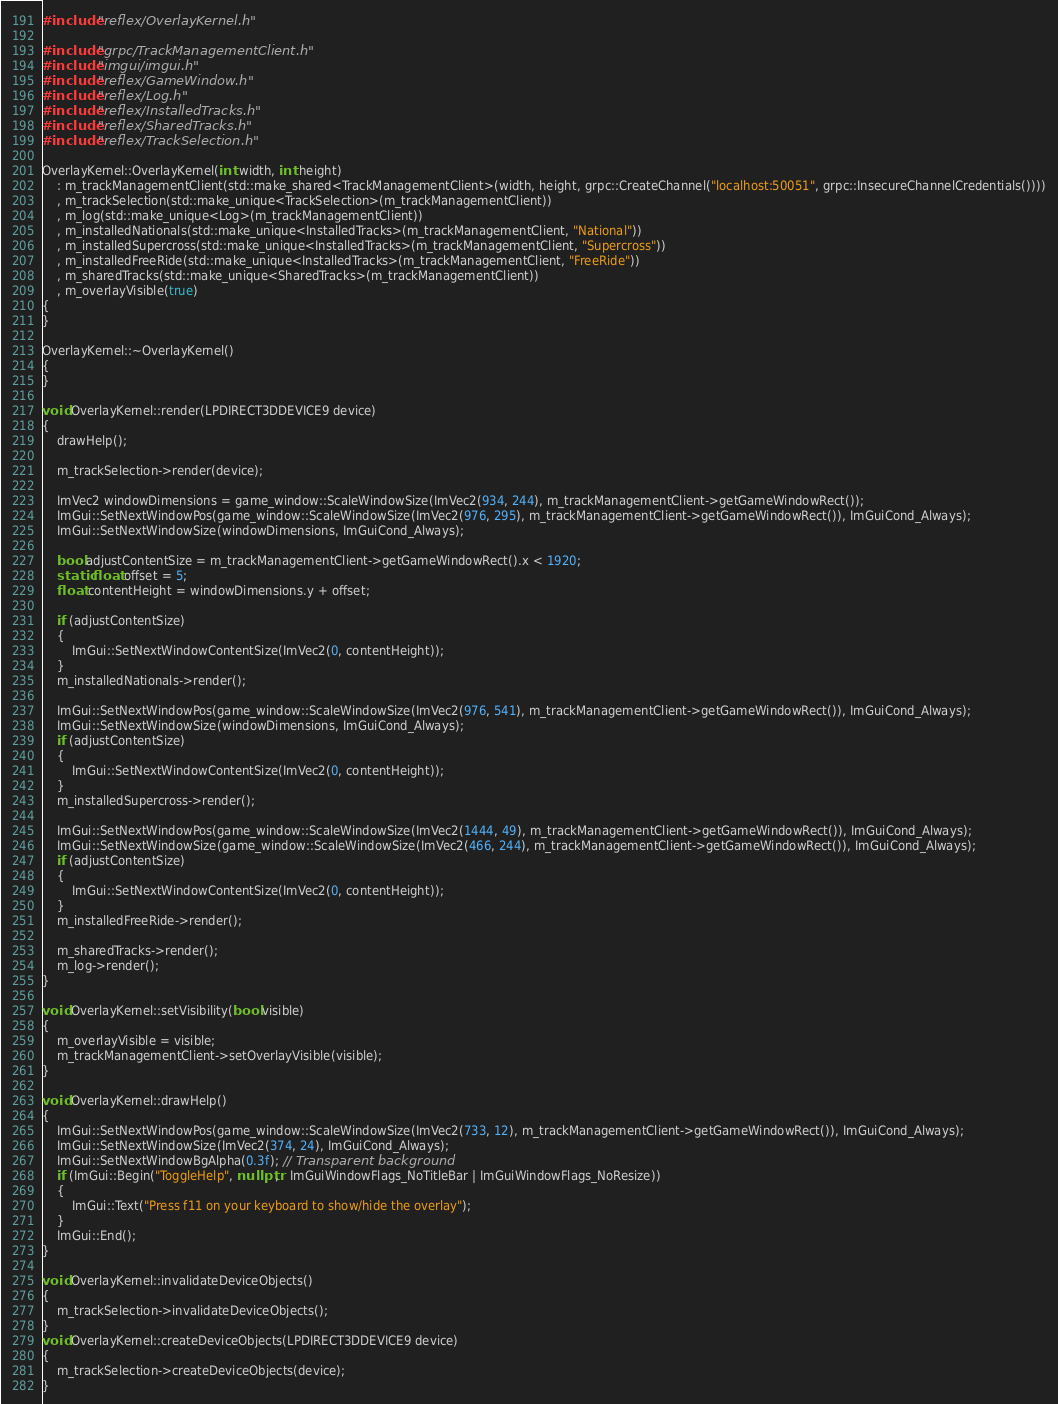<code> <loc_0><loc_0><loc_500><loc_500><_C++_>#include "reflex/OverlayKernel.h"

#include "grpc/TrackManagementClient.h"
#include "imgui/imgui.h"
#include "reflex/GameWindow.h"
#include "reflex/Log.h"
#include "reflex/InstalledTracks.h"
#include "reflex/SharedTracks.h"
#include "reflex/TrackSelection.h"

OverlayKernel::OverlayKernel(int width, int height)
	: m_trackManagementClient(std::make_shared<TrackManagementClient>(width, height, grpc::CreateChannel("localhost:50051", grpc::InsecureChannelCredentials())))
	, m_trackSelection(std::make_unique<TrackSelection>(m_trackManagementClient))
	, m_log(std::make_unique<Log>(m_trackManagementClient))
	, m_installedNationals(std::make_unique<InstalledTracks>(m_trackManagementClient, "National"))
	, m_installedSupercross(std::make_unique<InstalledTracks>(m_trackManagementClient, "Supercross"))
	, m_installedFreeRide(std::make_unique<InstalledTracks>(m_trackManagementClient, "FreeRide"))
	, m_sharedTracks(std::make_unique<SharedTracks>(m_trackManagementClient))
	, m_overlayVisible(true)
{
}

OverlayKernel::~OverlayKernel()
{
}

void OverlayKernel::render(LPDIRECT3DDEVICE9 device)
{
	drawHelp();

	m_trackSelection->render(device);

	ImVec2 windowDimensions = game_window::ScaleWindowSize(ImVec2(934, 244), m_trackManagementClient->getGameWindowRect());
	ImGui::SetNextWindowPos(game_window::ScaleWindowSize(ImVec2(976, 295), m_trackManagementClient->getGameWindowRect()), ImGuiCond_Always);
	ImGui::SetNextWindowSize(windowDimensions, ImGuiCond_Always);
	
	bool adjustContentSize = m_trackManagementClient->getGameWindowRect().x < 1920;
	static float offset = 5;
	float contentHeight = windowDimensions.y + offset;
	
	if (adjustContentSize)
	{
		ImGui::SetNextWindowContentSize(ImVec2(0, contentHeight));
	}
	m_installedNationals->render();

	ImGui::SetNextWindowPos(game_window::ScaleWindowSize(ImVec2(976, 541), m_trackManagementClient->getGameWindowRect()), ImGuiCond_Always);
	ImGui::SetNextWindowSize(windowDimensions, ImGuiCond_Always);
	if (adjustContentSize)
	{
		ImGui::SetNextWindowContentSize(ImVec2(0, contentHeight));
	}
	m_installedSupercross->render();

	ImGui::SetNextWindowPos(game_window::ScaleWindowSize(ImVec2(1444, 49), m_trackManagementClient->getGameWindowRect()), ImGuiCond_Always);
	ImGui::SetNextWindowSize(game_window::ScaleWindowSize(ImVec2(466, 244), m_trackManagementClient->getGameWindowRect()), ImGuiCond_Always);
	if (adjustContentSize)
	{
		ImGui::SetNextWindowContentSize(ImVec2(0, contentHeight));
	}
	m_installedFreeRide->render();

	m_sharedTracks->render();
	m_log->render();
}

void OverlayKernel::setVisibility(bool visible)
{
	m_overlayVisible = visible;
	m_trackManagementClient->setOverlayVisible(visible);
}

void OverlayKernel::drawHelp()
{
	ImGui::SetNextWindowPos(game_window::ScaleWindowSize(ImVec2(733, 12), m_trackManagementClient->getGameWindowRect()), ImGuiCond_Always);
	ImGui::SetNextWindowSize(ImVec2(374, 24), ImGuiCond_Always);
	ImGui::SetNextWindowBgAlpha(0.3f); // Transparent background
	if (ImGui::Begin("ToggleHelp", nullptr,   ImGuiWindowFlags_NoTitleBar | ImGuiWindowFlags_NoResize))
	{
		ImGui::Text("Press f11 on your keyboard to show/hide the overlay");
	}
	ImGui::End();
}

void OverlayKernel::invalidateDeviceObjects()
{
	m_trackSelection->invalidateDeviceObjects();
}
void OverlayKernel::createDeviceObjects(LPDIRECT3DDEVICE9 device)
{
	m_trackSelection->createDeviceObjects(device);
}

</code> 